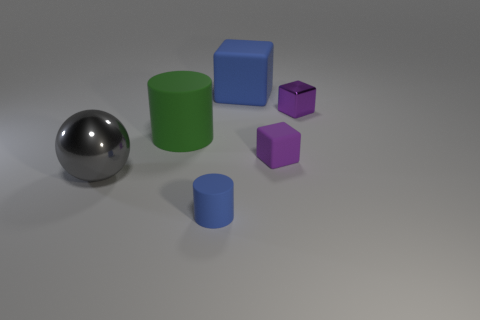How many balls are either tiny purple metal objects or big blue matte objects? 0 